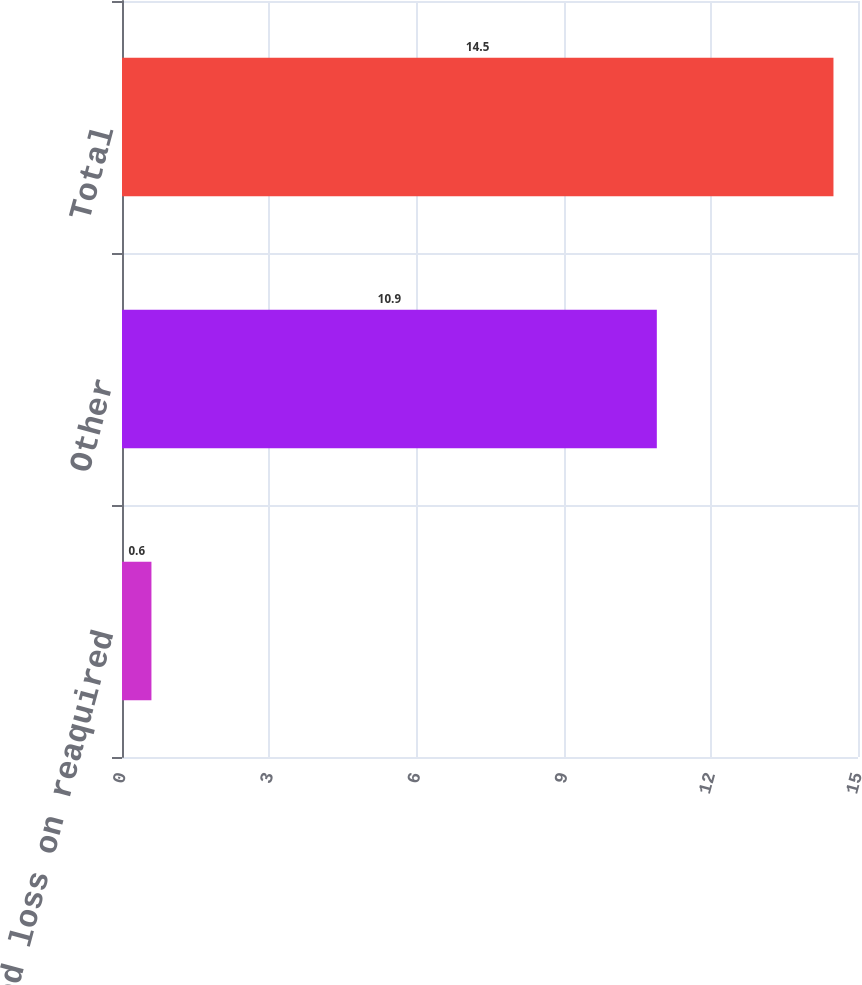Convert chart. <chart><loc_0><loc_0><loc_500><loc_500><bar_chart><fcel>Unamortized loss on reaquired<fcel>Other<fcel>Total<nl><fcel>0.6<fcel>10.9<fcel>14.5<nl></chart> 